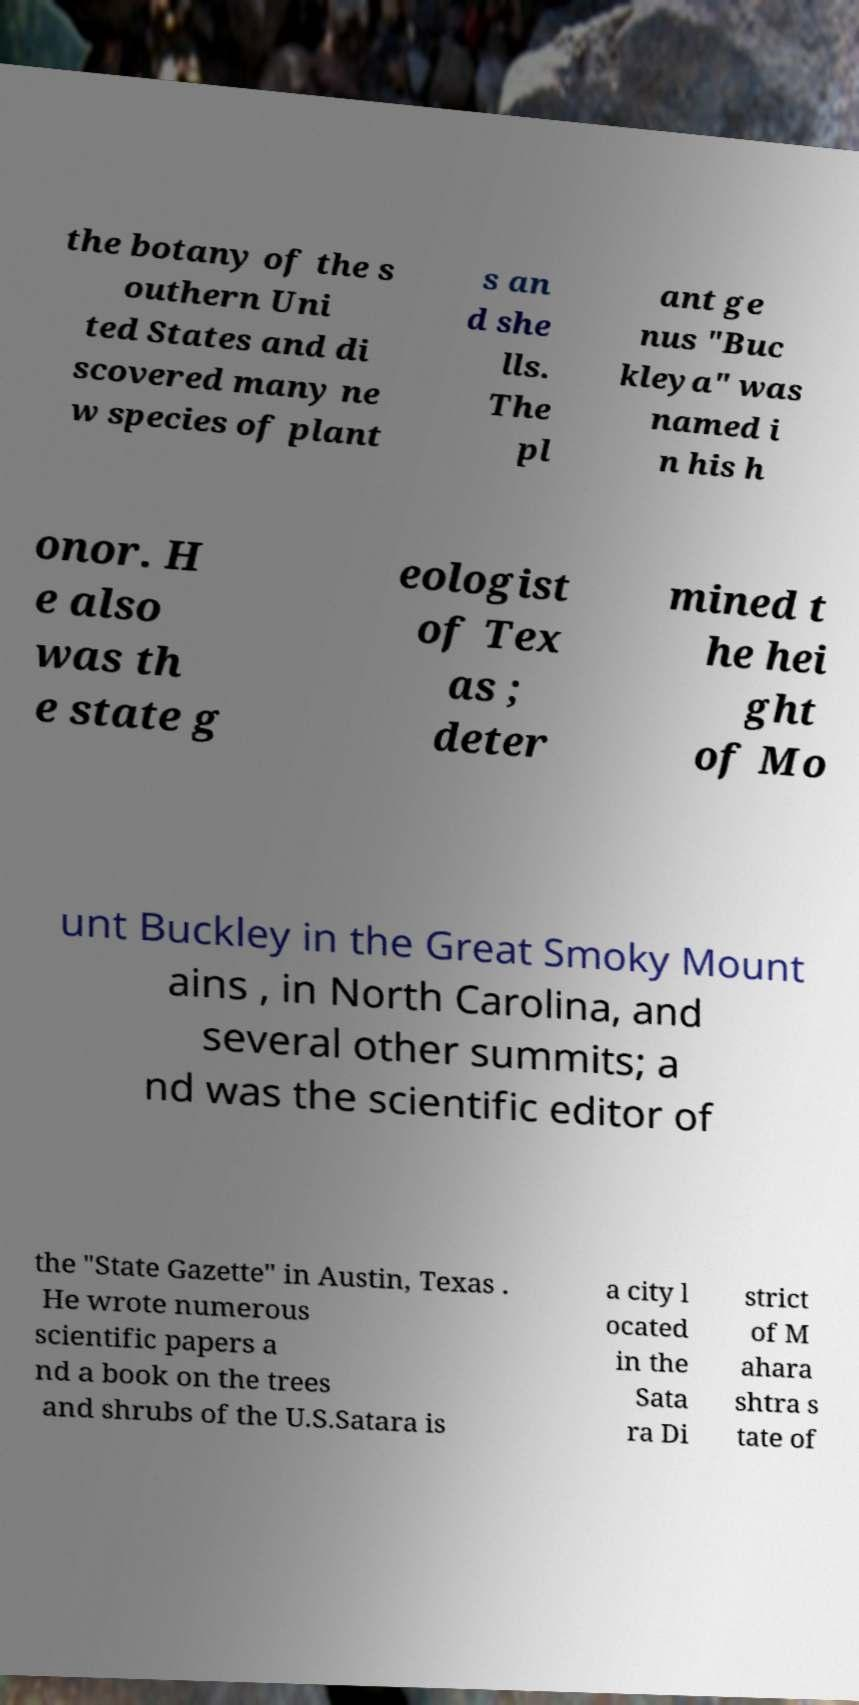Could you extract and type out the text from this image? the botany of the s outhern Uni ted States and di scovered many ne w species of plant s an d she lls. The pl ant ge nus "Buc kleya" was named i n his h onor. H e also was th e state g eologist of Tex as ; deter mined t he hei ght of Mo unt Buckley in the Great Smoky Mount ains , in North Carolina, and several other summits; a nd was the scientific editor of the "State Gazette" in Austin, Texas . He wrote numerous scientific papers a nd a book on the trees and shrubs of the U.S.Satara is a city l ocated in the Sata ra Di strict of M ahara shtra s tate of 